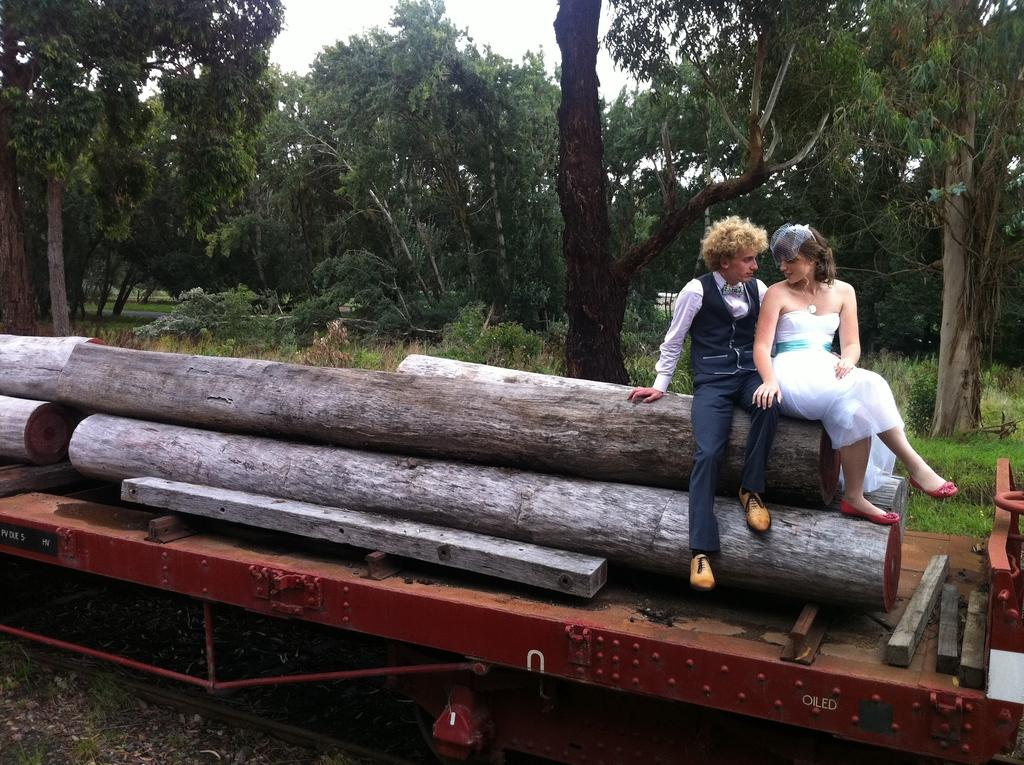Who can be seen in the image? There is a man and a woman in the image. What are they sitting on? They are both sitting on wooden blocks. Where are they located? They are on a train. What can be seen in the background of the image? There are trees, plants, and the sky visible in the background. What type of beef is being served on the train in the image? There is no beef present in the image; it features a man and a woman sitting on wooden blocks on a train. 